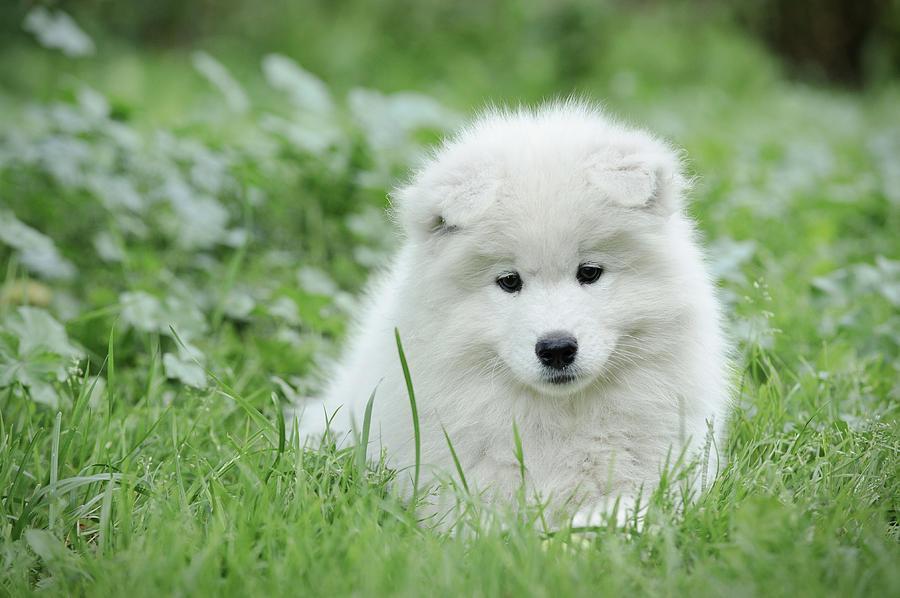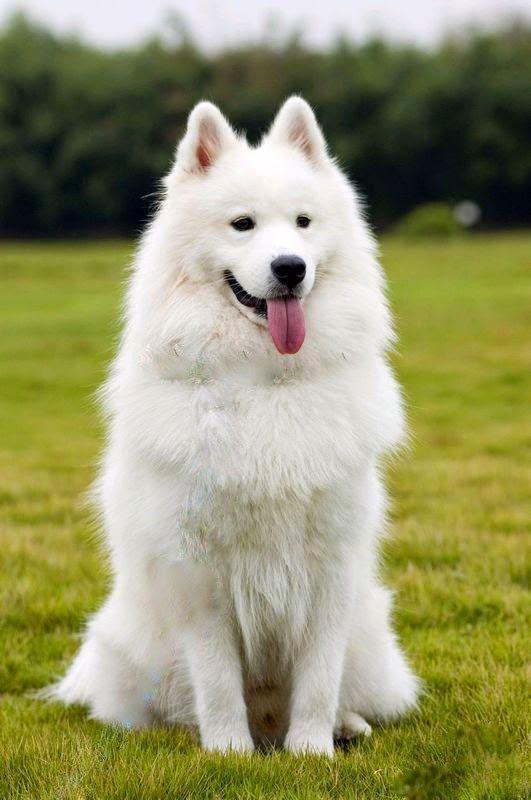The first image is the image on the left, the second image is the image on the right. Given the left and right images, does the statement "There are two dogs" hold true? Answer yes or no. Yes. 